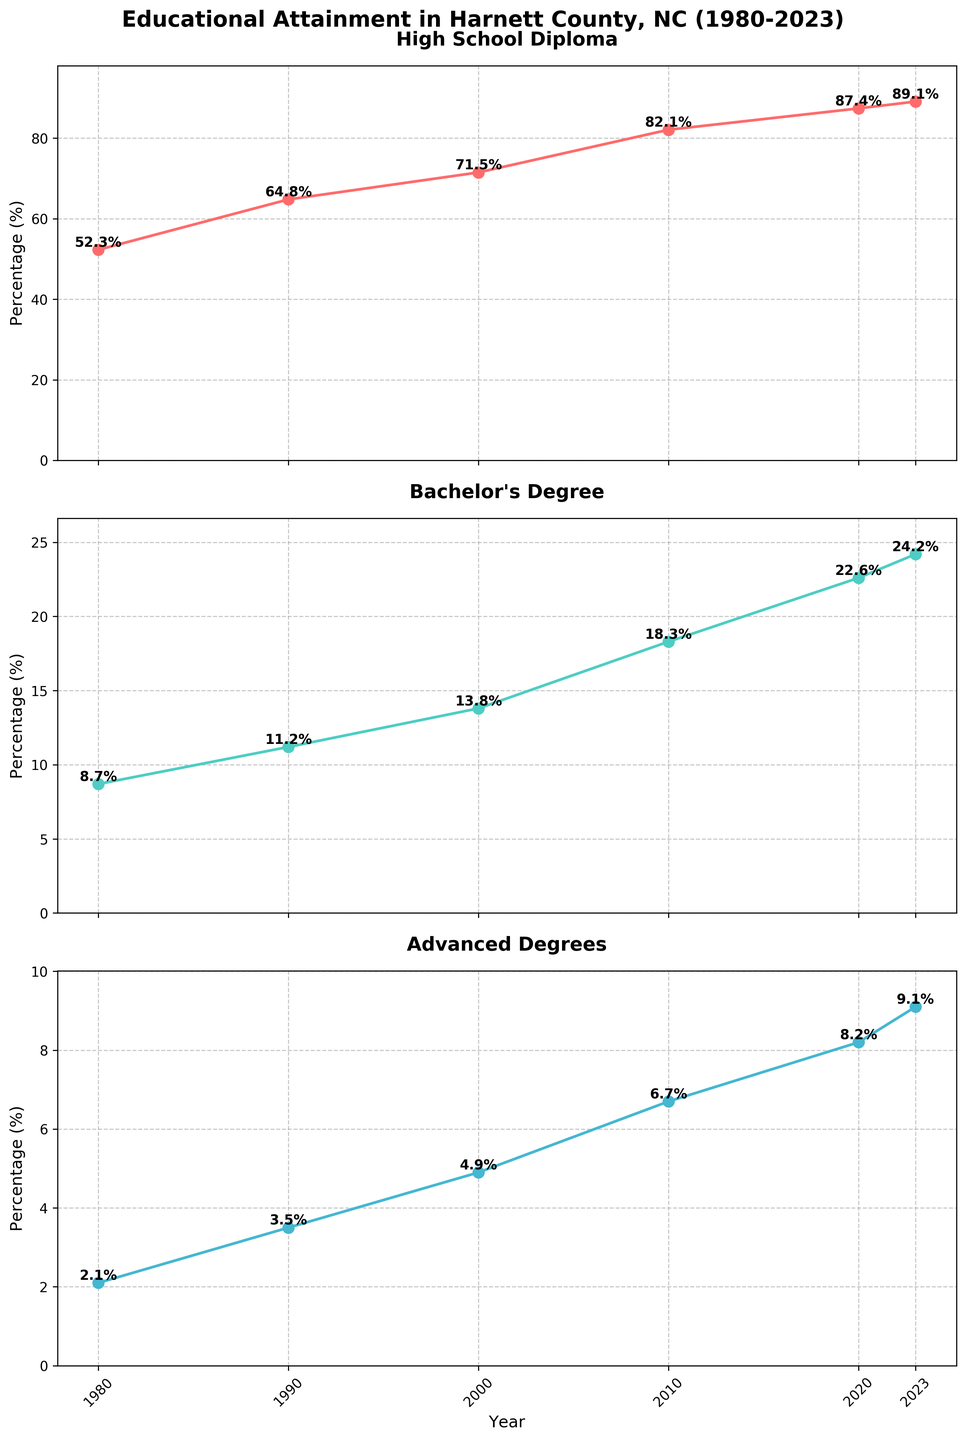What's the title of the figure? The title of the figure is displayed prominently at the top.
Answer: Educational Attainment in Harnett County, NC (1980-2023) What is the percentage of residents with a high school diploma in 1990? This value is directly shown in the High School Diploma subplot at the 1990 tick mark.
Answer: 64.8% Which year has the highest percentage of residents with an advanced degree? By examining the Advanced Degrees subplot and comparing the percentages visually, the highest value is in 2023.
Answer: 2023 By how much did the percentage of residents with a bachelor's degree increase from 1980 to 2020? Identify the percentages for 1980 (8.7%) and 2020 (22.6%) in the Bachelor's Degree subplot and calculate the difference: 22.6% - 8.7%.
Answer: 13.9% What is the trend of the high school diploma attainment between 1980 and 2023? Observing the High School Diploma subplot, the line shows a consistent upward trend from 1980 (52.3%) to 2023 (89.1%).
Answer: Consistent increase Which educational level shows the smallest percentage growth from 1980 to 2023? To determine this, calculate the percentage growth for each level:
High School: 89.1% - 52.3% = 36.8%
Bachelor's: 24.2% - 8.7% = 15.5%
Advanced Degrees: 9.1% - 2.1% = 7.0%
The smallest growth is for Advanced Degrees.
Answer: Advanced Degrees What is the average percentage of residents with a bachelor's degree over all the years? Calculate the average by summing the percentages for Bachelor's Degree subplot and dividing by the number of years:
(8.7% + 11.2% + 13.8% + 18.3% + 22.6% + 24.2%) / 6 = 16.3%
Answer: 16.3% Are there any years where the percentage of residents with an advanced degree is twice the percentage from the previous decade? Examination of the Advanced Degrees subplot shows:
1990 vs 1980: 3.5% is not twice 2.1%
2000 vs 1990: 4.9% is not twice 3.5%
2010 vs 2000: 6.7% is not twice 4.9%
2020 vs 2010: 8.2% is not twice 6.7%
2023 vs 2020: 9.1% is not twice 8.2%
Thus, no year has doubled from the previous decade.
Answer: No In what year did the percentage of residents with a high school diploma first exceed 80%? The High School Diploma subplot shows this value exceeding 80% in 2010.
Answer: 2010 Which educational level shows the most significant percentage increase between 1980 and 1990? Calculate the differences for each subplot:
High School: 64.8% - 52.3% = 12.5%
Bachelor's: 11.2% - 8.7% = 2.5%
Advanced Degrees: 3.5% - 2.1% = 1.4%
The greatest increase is in High School diplomas with change of 12.5%.
Answer: High School 